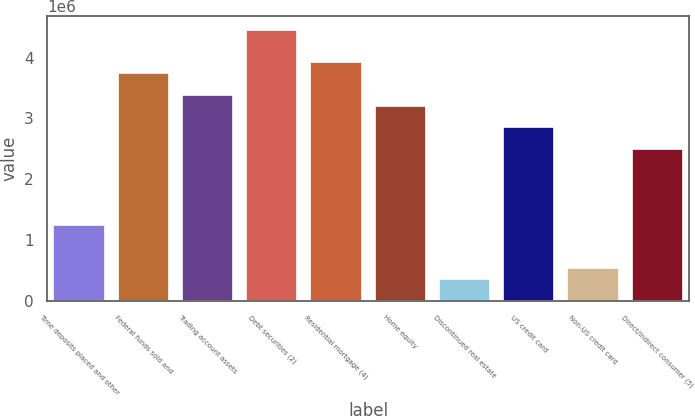Convert chart. <chart><loc_0><loc_0><loc_500><loc_500><bar_chart><fcel>Time deposits placed and other<fcel>Federal funds sold and<fcel>Trading account assets<fcel>Debt securities (2)<fcel>Residential mortgage (4)<fcel>Home equity<fcel>Discontinued real estate<fcel>US credit card<fcel>Non-US credit card<fcel>Direct/Indirect consumer (5)<nl><fcel>1.24923e+06<fcel>3.74476e+06<fcel>3.38825e+06<fcel>4.45777e+06<fcel>3.92301e+06<fcel>3.21e+06<fcel>357970<fcel>2.8535e+06<fcel>536222<fcel>2.49699e+06<nl></chart> 